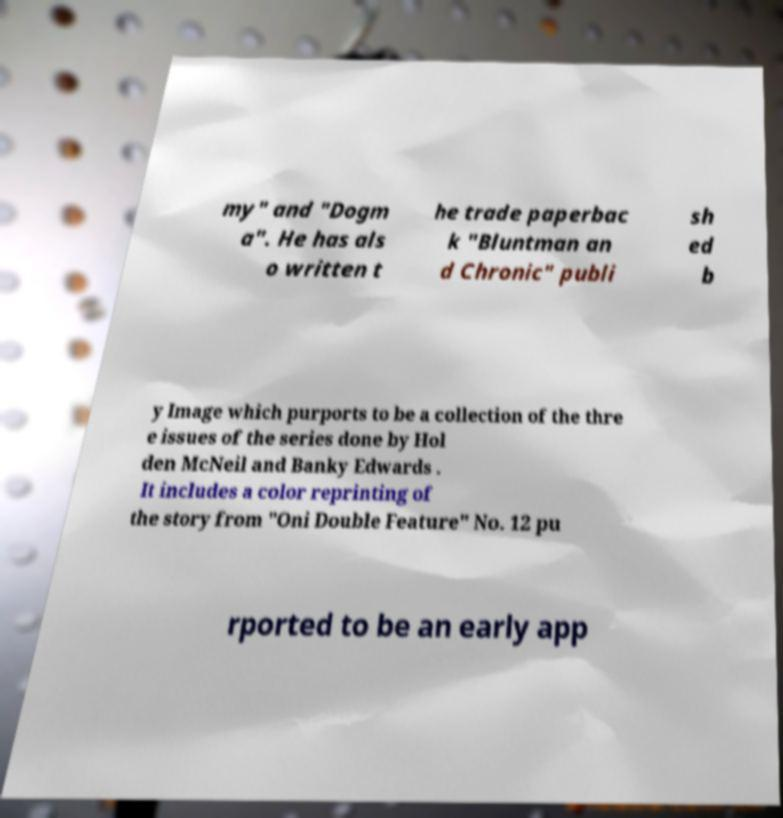Can you accurately transcribe the text from the provided image for me? my" and "Dogm a". He has als o written t he trade paperbac k "Bluntman an d Chronic" publi sh ed b y Image which purports to be a collection of the thre e issues of the series done by Hol den McNeil and Banky Edwards . It includes a color reprinting of the story from "Oni Double Feature" No. 12 pu rported to be an early app 